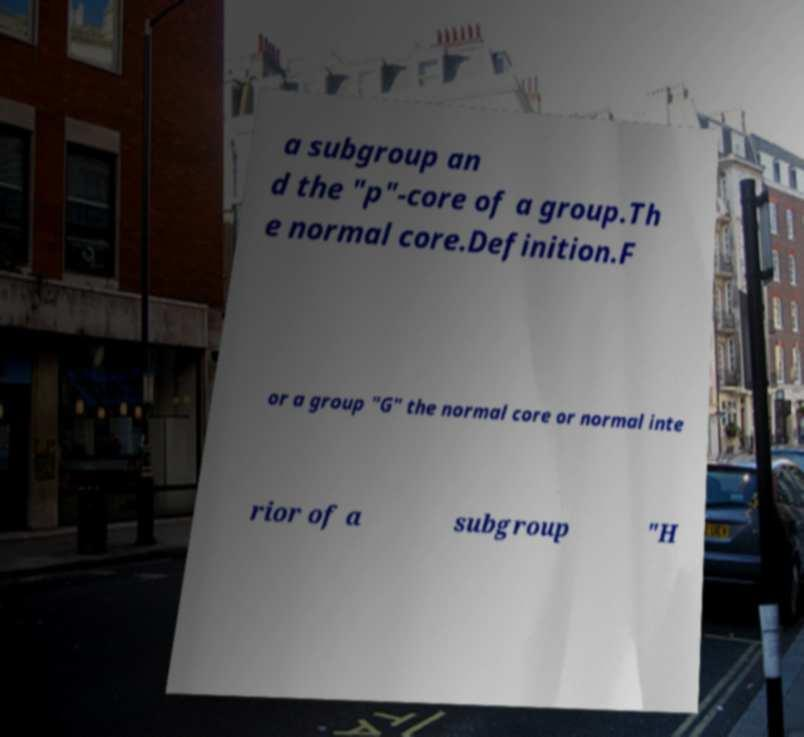Can you accurately transcribe the text from the provided image for me? a subgroup an d the "p"-core of a group.Th e normal core.Definition.F or a group "G" the normal core or normal inte rior of a subgroup "H 